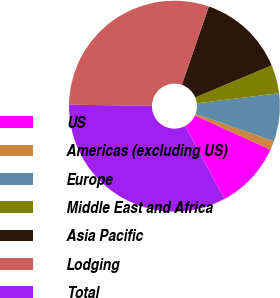Convert chart. <chart><loc_0><loc_0><loc_500><loc_500><pie_chart><fcel>US<fcel>Americas (excluding US)<fcel>Europe<fcel>Middle East and Africa<fcel>Asia Pacific<fcel>Lodging<fcel>Total<nl><fcel>10.38%<fcel>1.35%<fcel>7.37%<fcel>4.36%<fcel>13.39%<fcel>30.06%<fcel>33.07%<nl></chart> 